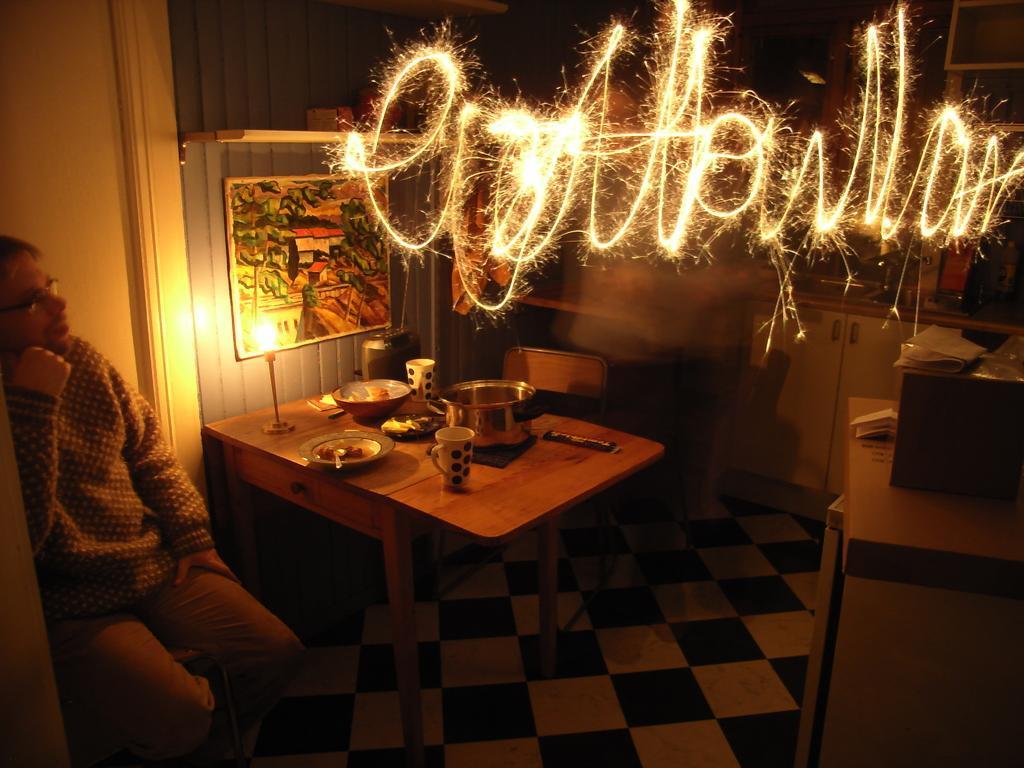Could you give a brief overview of what you see in this image? In a room there is a man to the left bottom side is sitting. Behind him there is a door. Beside him there is a table. On the table there is a cup, plate, bowl, lamp. To the wall there is a photo frame. And to the right side wall there is a frame. On the cupboard there is a box. And on the top there is a word written with sparkles. 